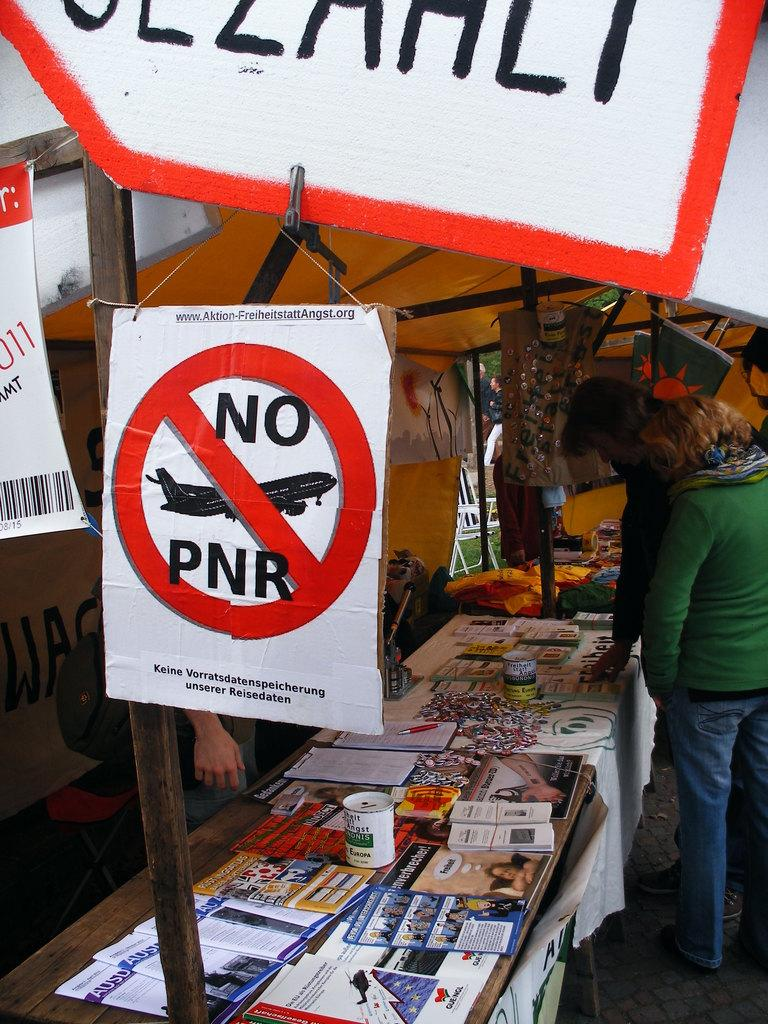<image>
Share a concise interpretation of the image provided. A protest sign at a stall states No PNR. 